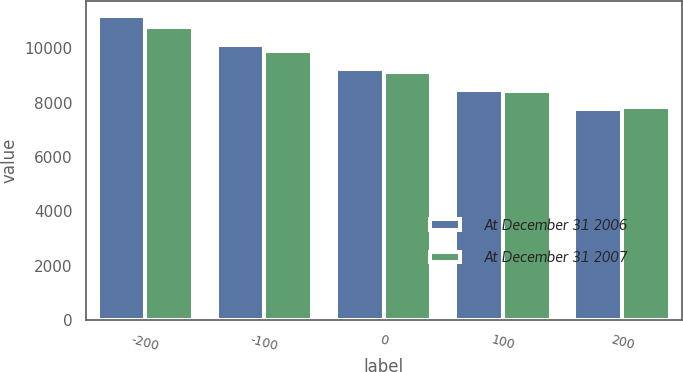Convert chart. <chart><loc_0><loc_0><loc_500><loc_500><stacked_bar_chart><ecel><fcel>-200<fcel>-100<fcel>0<fcel>100<fcel>200<nl><fcel>At December 31 2006<fcel>11188<fcel>10132<fcel>9226<fcel>8445<fcel>7765<nl><fcel>At December 31 2007<fcel>10777<fcel>9901<fcel>9127<fcel>8439<fcel>7837<nl></chart> 